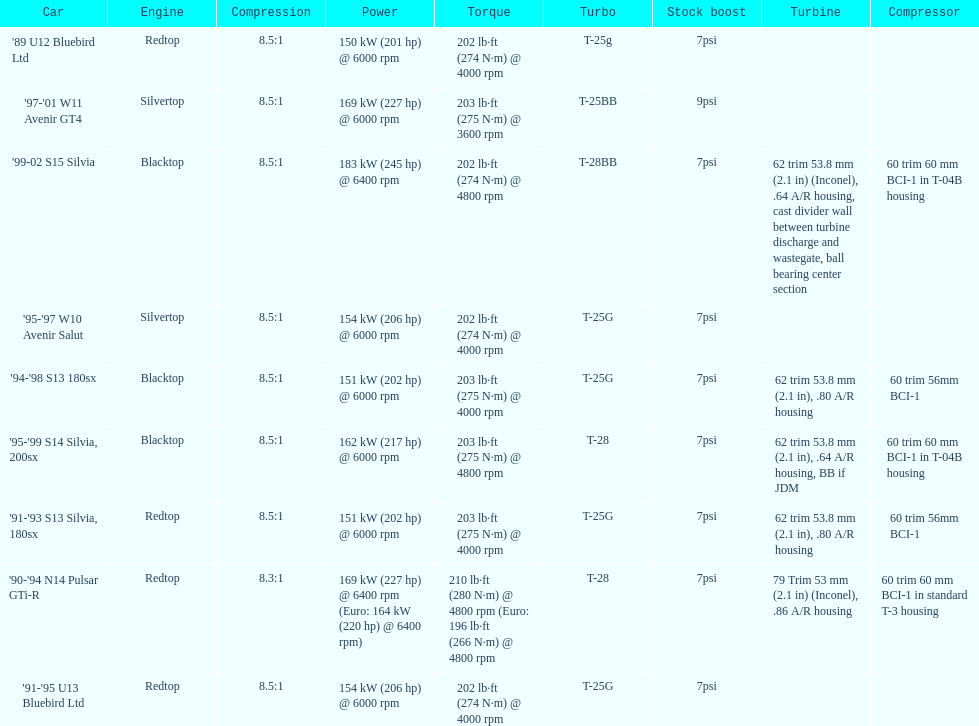Which engine(s) has the least amount of power? Redtop. 